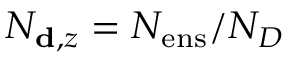Convert formula to latex. <formula><loc_0><loc_0><loc_500><loc_500>N _ { d , z } = N _ { e n s } / N _ { D }</formula> 